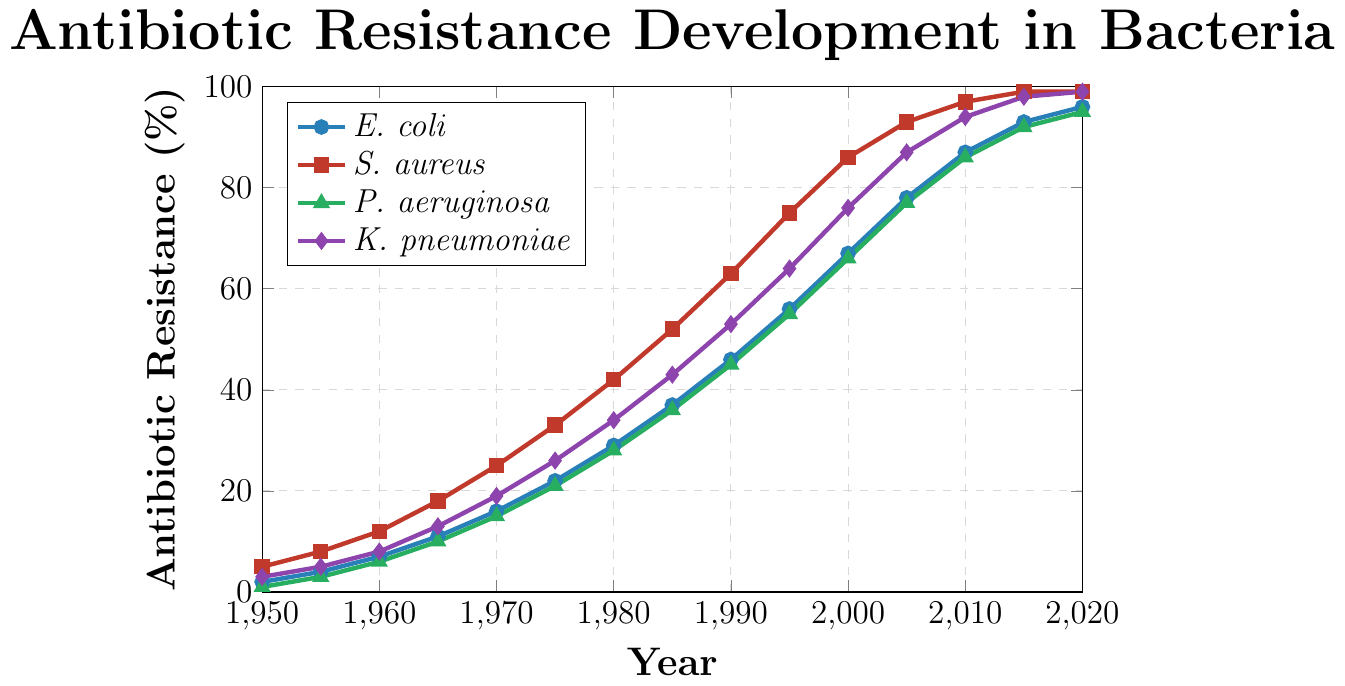What's the average antibiotic resistance for \textit{E. coli} between 1950 and 1970? To find the average, sum the resistance values for \(1950 (2) + 1955 (4) + 1960 (7) + 1965 (11) + 1970 (16)\), and then divide by the number of years, which is 5. So, \( (2 + 4 + 7 + 11 + 16)/5 = 40/5 = 8\)
Answer: 8 Which bacteria species had the highest rate of antibiotic resistance in 2010? Look at the antibiotic resistance values for all species in 2010. \textit{E. coli} has 87%, \textit{S. aureus} has 97%, \textit{P. aeruginosa} has 86%, and \textit{K. pneumoniae} has 94%. The highest value is 97% for \textit{S. aureus}
Answer: \textit{S. aureus} Between 1960 and 1980, which species showed the steepest increase in antibiotic resistance? Calculate the increase in resistance for each species between 1960 and 1980. \textit{E. coli} increased by \(29 - 7 = 22\), \textit{S. aureus} by \(42 - 12 = 30\), \textit{P. aeruginosa} by \(28 - 6 = 22\), and \textit{K. pneumoniae} by \(34 - 8 = 26\). \textit{S. aureus} shows the steepest increase of 30%
Answer: \textit{S. aureus} What's the difference in antibiotic resistance values between \textit{P. aeruginosa} and \textit{E. coli} in the year 2000? Find the resistance values for both bacteria in 2000, \textit{P. aeruginosa} is 66% and \textit{E. coli} is 67%. The difference is \(67 - 66 = 1\)
Answer: 1 In which decade did \textit{K. pneumoniae} reach 50% antibiotic resistance? Review the resistance values for \textit{K. pneumoniae} in each decade: it reaches 53% in 1990. Therefore, \textit{K. pneumoniae} reached 50% some time during the 1980s
Answer: 1980s What color represents \textit{S. aureus} in the plot? The bacteria species \textit{S. aureus} is represented with the color red in the plot, clearly noticeable by the square markers and the red line
Answer: Red Is there any bacteria species that reached 99% antibiotic resistance by 2020? Examine the values for 2020. Both \textit{S. aureus} and \textit{K. pneumoniae} reached 99% antibiotic resistance
Answer: \textit{S. aureus}, \textit{K. pneumoniae} What's the total increase in resistance for \textit{E. coli} from 1950 to 2020? The resistance values for \textit{E. coli} in 1950 and 2020 are 2% and 96%, respectively. The total increase is \(96 - 2 = 94\)
Answer: 94 How many times does the antibiotic resistance of \textit{P. aeruginosa} increase from 1950 to 2000? The resistance value for \textit{P. aeruginosa} in 1950 is 1%, and in 2000 is 66%. The increase factor is \(66/1 = 66\)
Answer: 66 